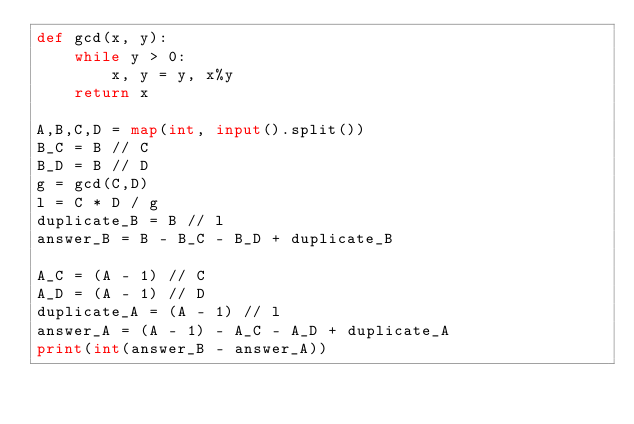Convert code to text. <code><loc_0><loc_0><loc_500><loc_500><_Python_>def gcd(x, y):
    while y > 0:
        x, y = y, x%y
    return x

A,B,C,D = map(int, input().split())
B_C = B // C
B_D = B // D
g = gcd(C,D)
l = C * D / g
duplicate_B = B // l
answer_B = B - B_C - B_D + duplicate_B

A_C = (A - 1) // C
A_D = (A - 1) // D
duplicate_A = (A - 1) // l
answer_A = (A - 1) - A_C - A_D + duplicate_A
print(int(answer_B - answer_A))
</code> 